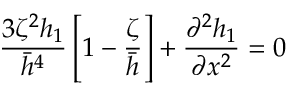Convert formula to latex. <formula><loc_0><loc_0><loc_500><loc_500>\frac { 3 \zeta ^ { 2 } h _ { 1 } } { \ B a r { h } ^ { 4 } } \left [ 1 - \frac { \zeta } { \ B a r { h } } \right ] + \frac { \partial ^ { 2 } h _ { 1 } } { \partial x ^ { 2 } } = 0</formula> 